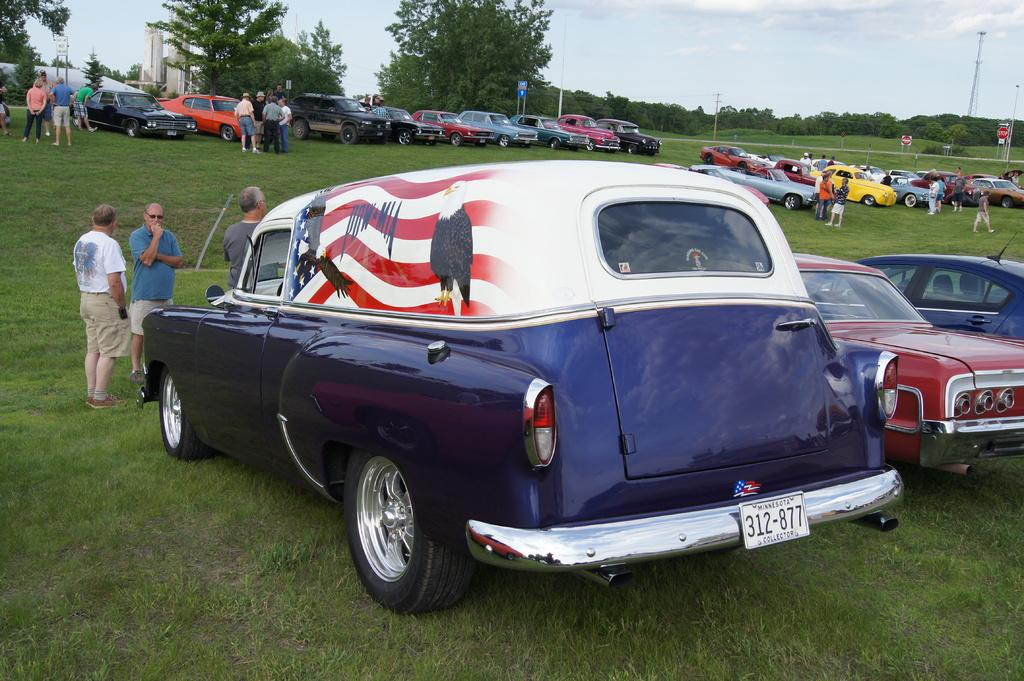What type of vehicles can be seen in the image? There are cars in the image. Who or what else is present in the image? There are people in the image. What is the color of the ground in the image? The ground is green in the image. What can be seen in the background of the image? There are trees and poles in the background of the image. What type of pet can be seen playing with a zipper in the image? There is no pet or zipper present in the image. How does the stretch of road in the image appear to be? The provided facts do not mention a stretch of road, so we cannot answer this question based on the given information. 